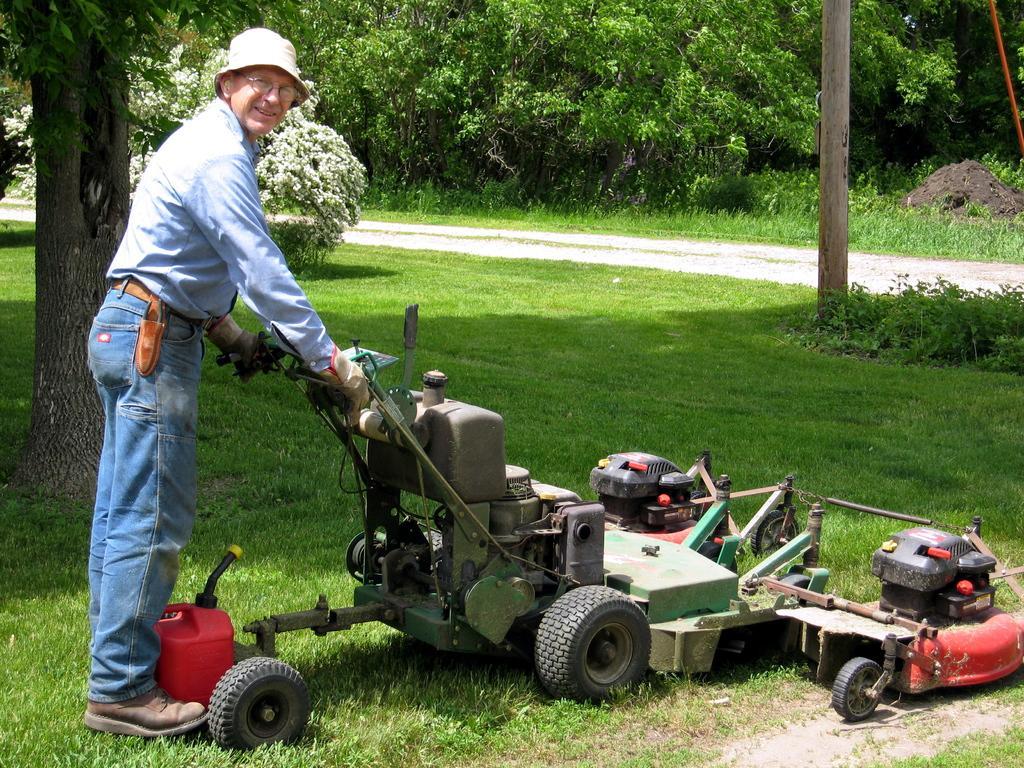How would you summarize this image in a sentence or two? In this image we can see a man standing and holding a lawn mower. At the bottom there is grass. In the background there are trees. 